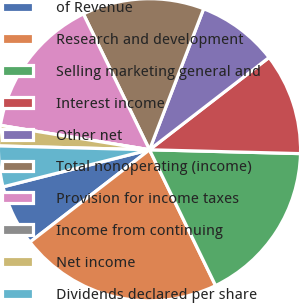<chart> <loc_0><loc_0><loc_500><loc_500><pie_chart><fcel>of Revenue<fcel>Research and development<fcel>Selling marketing general and<fcel>Interest income<fcel>Other net<fcel>Total nonoperating (income)<fcel>Provision for income taxes<fcel>Income from continuing<fcel>Net income<fcel>Dividends declared per share<nl><fcel>6.52%<fcel>21.74%<fcel>17.39%<fcel>10.87%<fcel>8.7%<fcel>13.04%<fcel>15.22%<fcel>0.0%<fcel>2.17%<fcel>4.35%<nl></chart> 